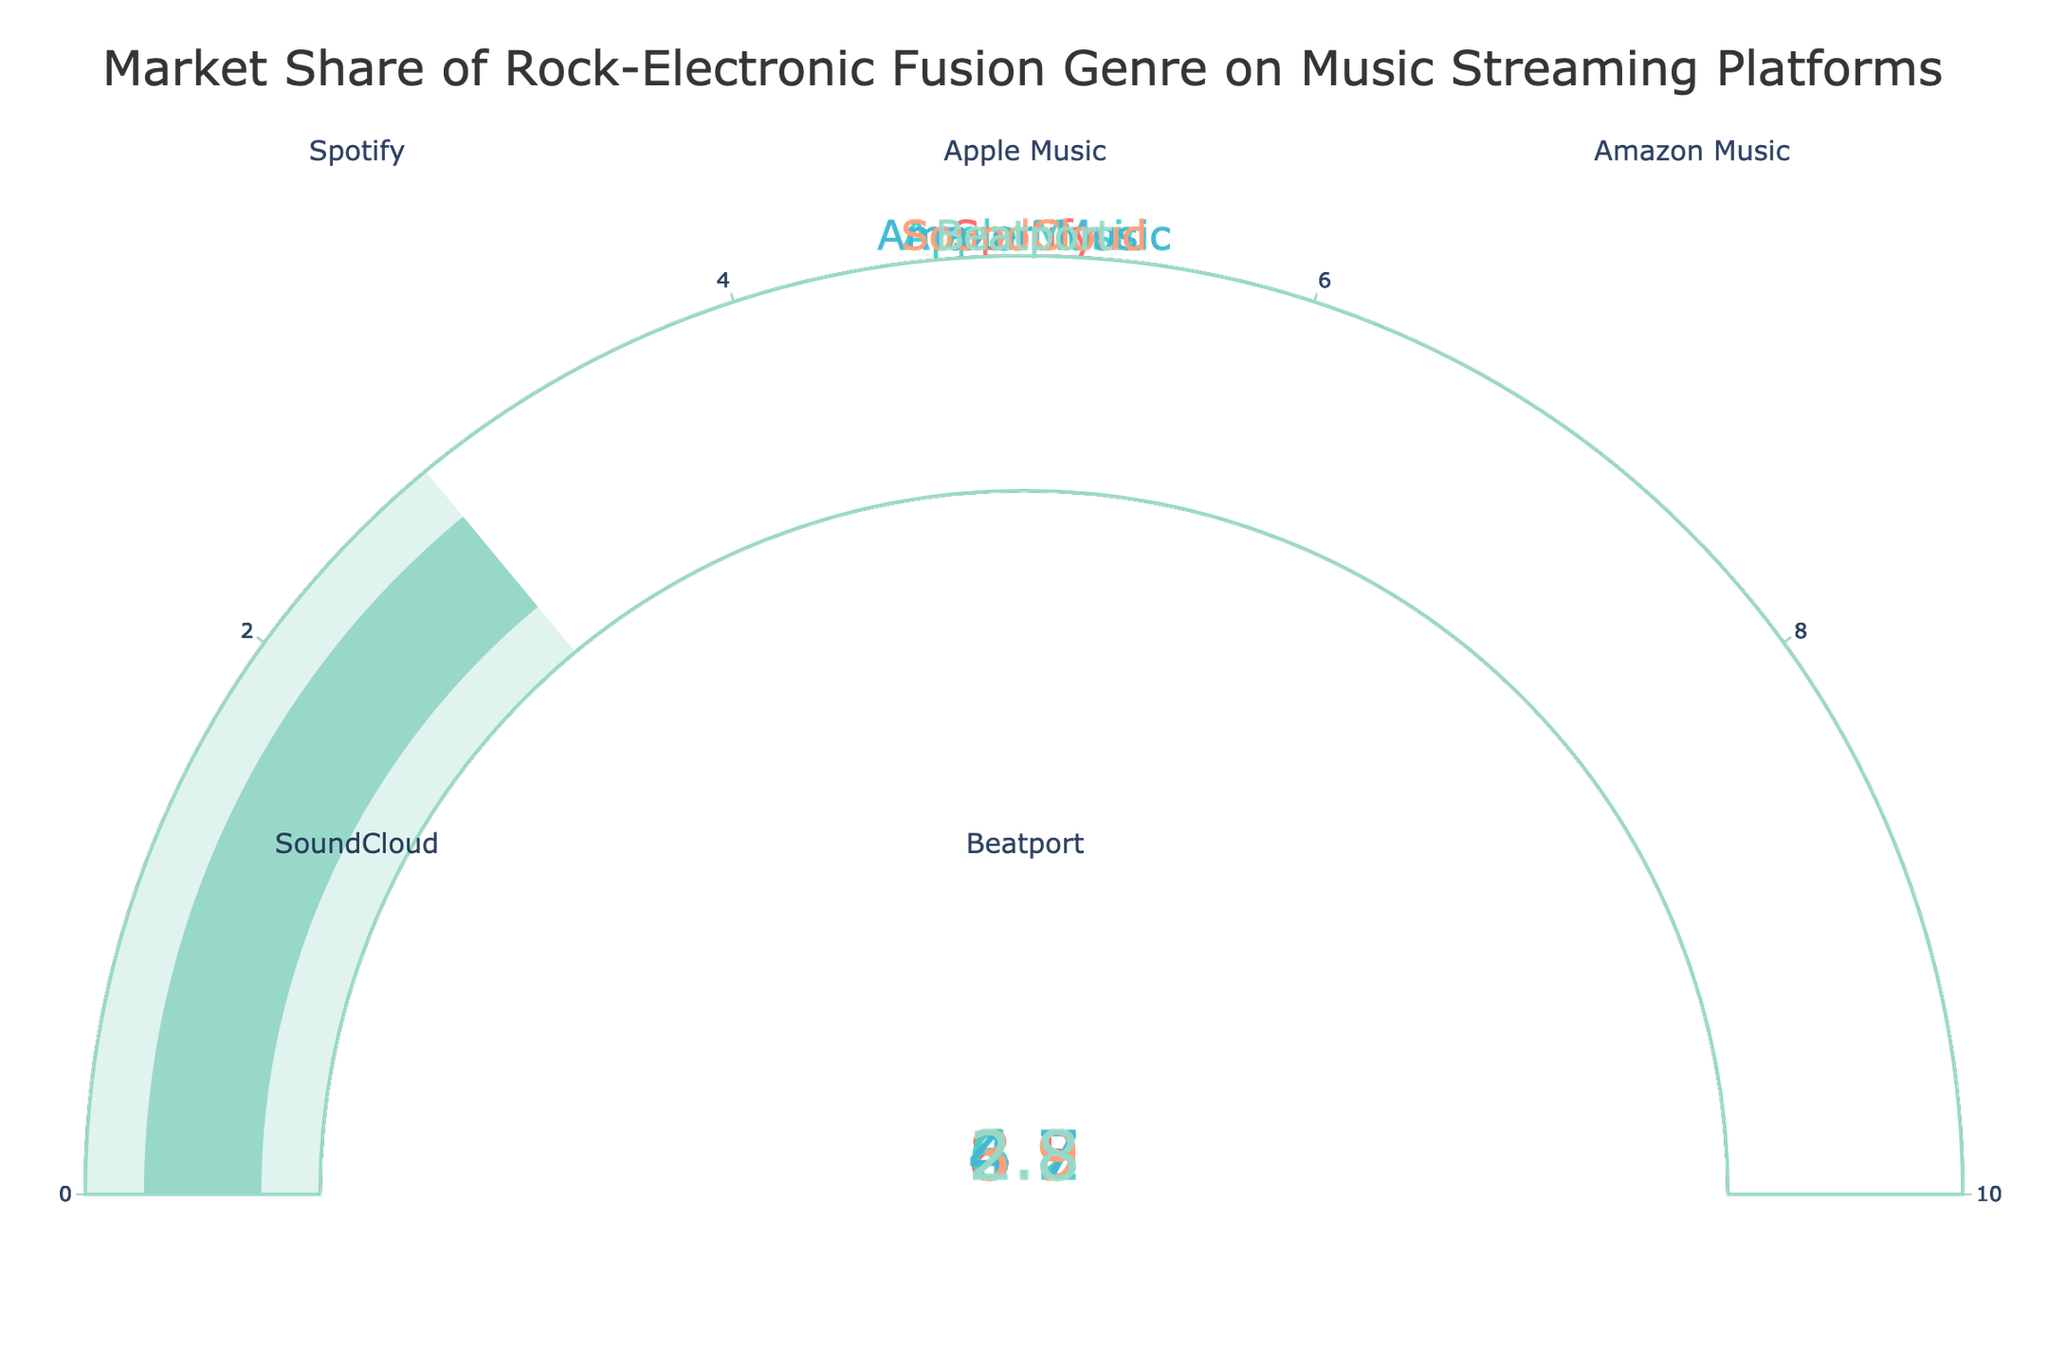What's the highest market share among the music streaming platforms? We can check each gauge to see the displayed number. Spotify has the highest market share with a value of 8.5.
Answer: 8.5 What's the difference in market share between Spotify and Apple Music? The market share for Spotify is 8.5, and for Apple Music, it is 6.2. Subtracting Apple Music's value from Spotify's gives us 8.5 - 6.2 = 2.3.
Answer: 2.3 Which platform has the lowest market share? We need to compare the values on each gauge. Beatport has the lowest market share with a value of 2.8.
Answer: Beatport What is the combined market share of Amazon Music and SoundCloud? The market share for Amazon Music is 4.7 and for SoundCloud, it's 3.9. Adding both values gives 4.7 + 3.9 = 8.6.
Answer: 8.6 How many platforms have a market share greater than 4? By checking each gauge, we see that Spotify (8.5), Apple Music (6.2), and Amazon Music (4.7) have market shares greater than 4. There are 3 platforms.
Answer: 3 What is the average market share of all the listed platforms? Summing all values gives 8.5 + 6.2 + 4.7 + 3.9 + 2.8 = 26.1. There are 5 platforms, so the average is 26.1 / 5 = 5.22.
Answer: 5.22 